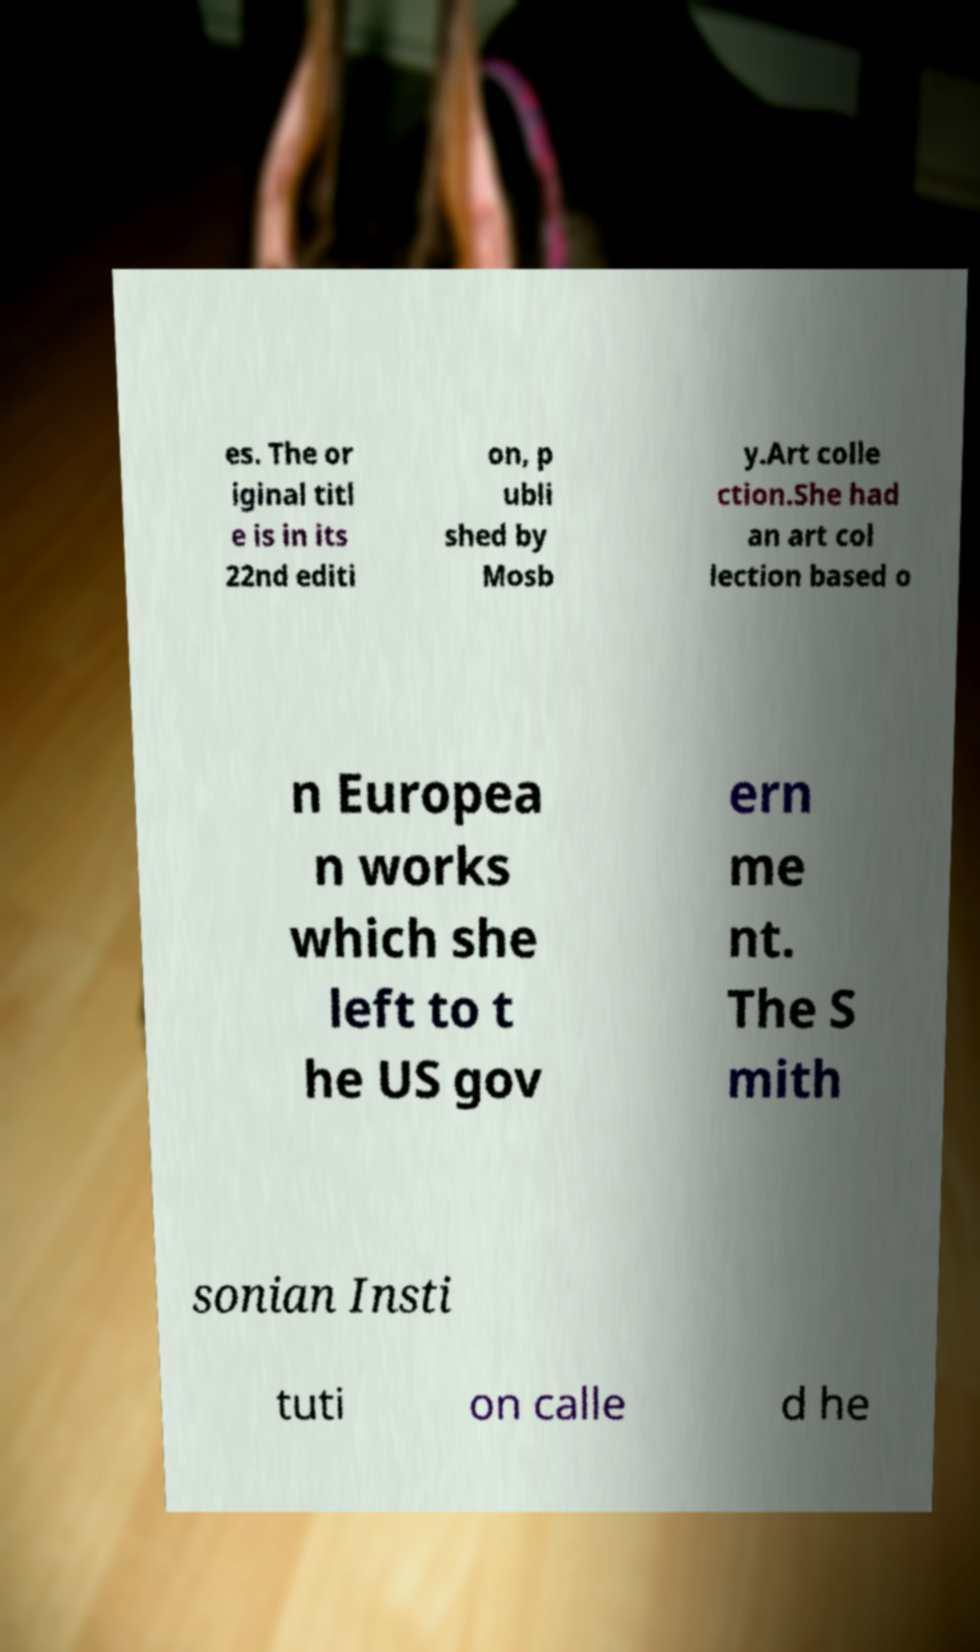Can you read and provide the text displayed in the image?This photo seems to have some interesting text. Can you extract and type it out for me? es. The or iginal titl e is in its 22nd editi on, p ubli shed by Mosb y.Art colle ction.She had an art col lection based o n Europea n works which she left to t he US gov ern me nt. The S mith sonian Insti tuti on calle d he 